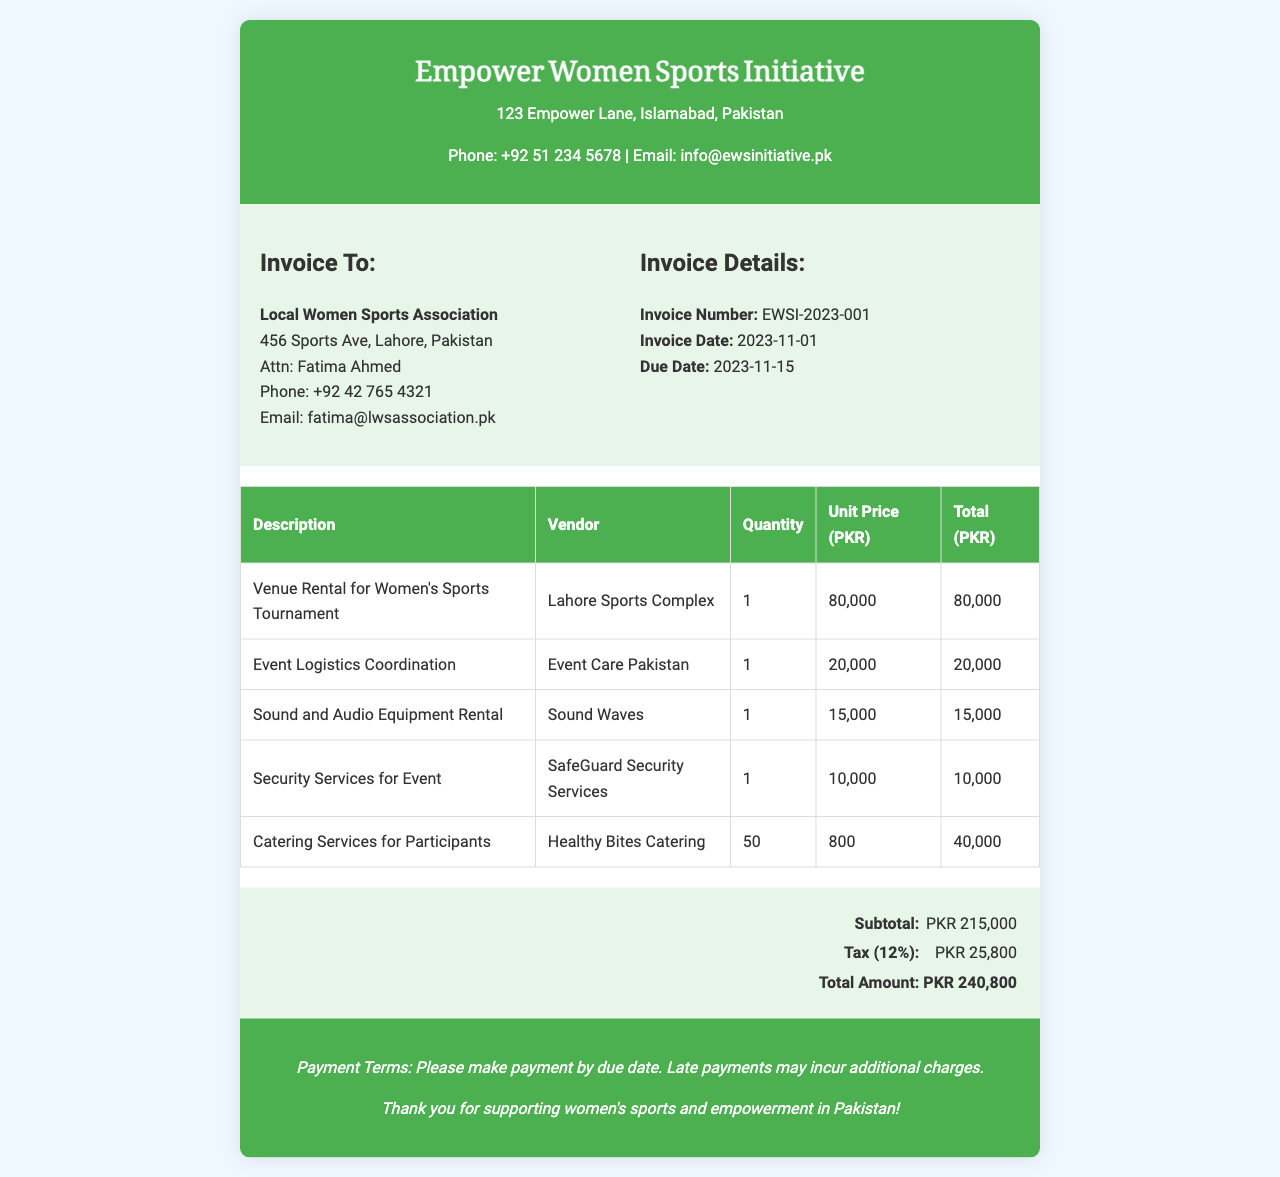What is the invoice number? The invoice number is specifically stated in the document under Invoice Details.
Answer: EWSI-2023-001 What is the total amount due? The total amount due can be found in the invoice total section.
Answer: PKR 240,800 Who is the vendor for sound and audio equipment? The vendor for sound and audio equipment is listed in the services provided table.
Answer: Sound Waves What is the due date for payment? The due date is mentioned in the Invoice Details section of the document.
Answer: 2023-11-15 How much is charged for catering services? The charge for catering services is provided in the cost breakdown of services.
Answer: PKR 40,000 What is the tax percentage applied? The tax percentage is included in the invoice total breakdown.
Answer: 12% What is the name of the organization being invoiced? The name of the organization is clearly indicated in the Invoice To section.
Answer: Local Women Sports Association What service is provided by SafeGuard? The specific service is detailed in the cost breakdown of services provided.
Answer: Security Services for Event What is the subtotal before tax? The subtotal is listed in the invoice total breakdown.
Answer: PKR 215,000 